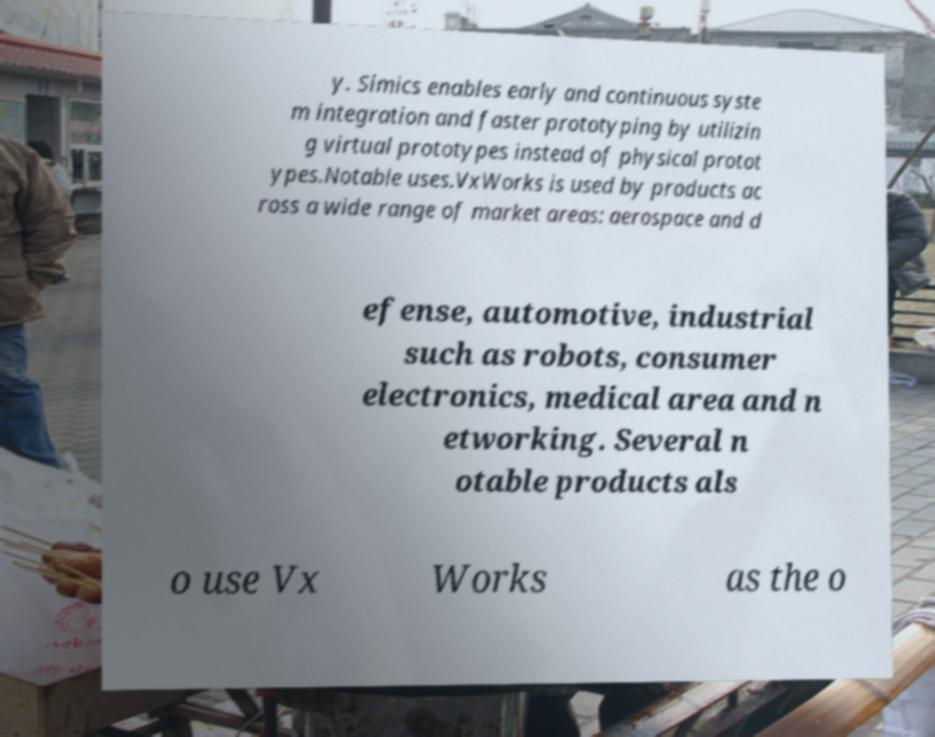I need the written content from this picture converted into text. Can you do that? y. Simics enables early and continuous syste m integration and faster prototyping by utilizin g virtual prototypes instead of physical protot ypes.Notable uses.VxWorks is used by products ac ross a wide range of market areas: aerospace and d efense, automotive, industrial such as robots, consumer electronics, medical area and n etworking. Several n otable products als o use Vx Works as the o 